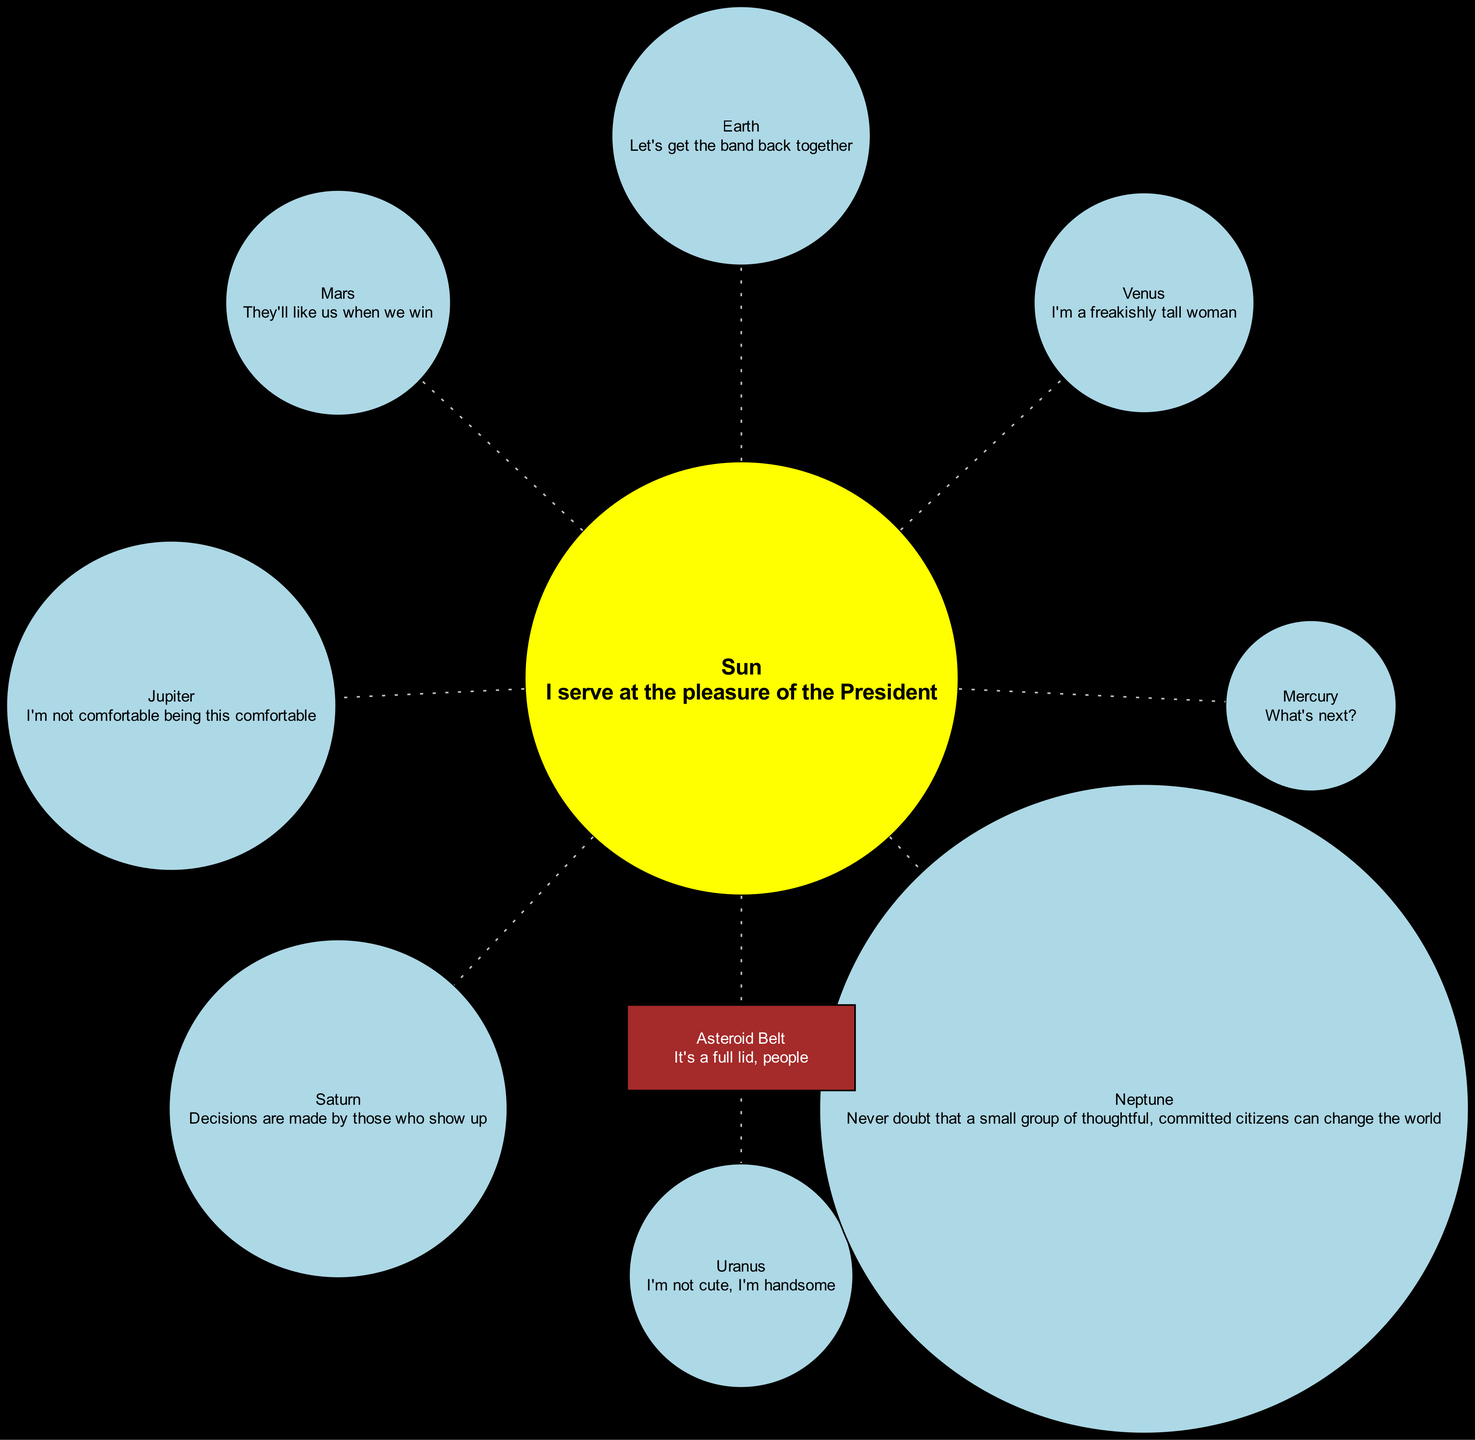What is the quote associated with the Sun? The diagram displays the Sun node with its quote, which is "I serve at the pleasure of the President". Thus, we simply read the quoted text beneath the Sun label.
Answer: I serve at the pleasure of the President How many planets are in the solar system as per the diagram? The diagram lists a total of 8 planets in the "planets" section, specifically Mercury, Venus, Earth, Mars, Jupiter, Saturn, Uranus, and Neptune. Counting these gives us the total number of planets.
Answer: 8 Which planet's quote mentions winning? The quote "They'll like us when we win" is associated with Mars, as seen in the planet’s details displayed in the diagram. We identify the text related to each planet and select Mars's quote.
Answer: Mars What color is the asteroid belt represented in the diagram? In the diagram, the asteroid belt is represented as a box filled with the color brown, which is explicitly stated under the attributes of that node.
Answer: Brown Which planet has the quote about being "freakishly tall"? The quote "I'm a freakishly tall woman" belongs to Venus, as indicated next to its respective planet node in the diagram. We locate this specific quote under the labeled planet node of Venus.
Answer: Venus What is the relationship between the Sun and the planets in the diagram? Each planet is connected to the Sun with a dotted (gray) edge, indicating a hierarchical relationship where the Sun is the central star and the planets orbit around it. Counting the dotted edges confirms each planet's connection to the Sun.
Answer: Dotted edges What is the label of the object located at the center of the diagram? The object at the center of the diagram is labeled "Sun". This is evident as the diagram explicitly provides a node for the Sun with its label.
Answer: Sun Which planet is represented with the quote about changing the world? The quote "Never doubt that a small group of thoughtful, committed citizens can change the world" is associated with Neptune, found in the planet's label in the diagram. We identify the text corresponding to Neptune.
Answer: Neptune What is the position of the asteroid belt in relation to the Sun? The asteroid belt is positioned directly below the Sun, indicated clearly by its coordinates (0,-3!) compared to the Sun's position. We analyze the positions to determine where the asteroid belt is placed in the layout.
Answer: Below the Sun 